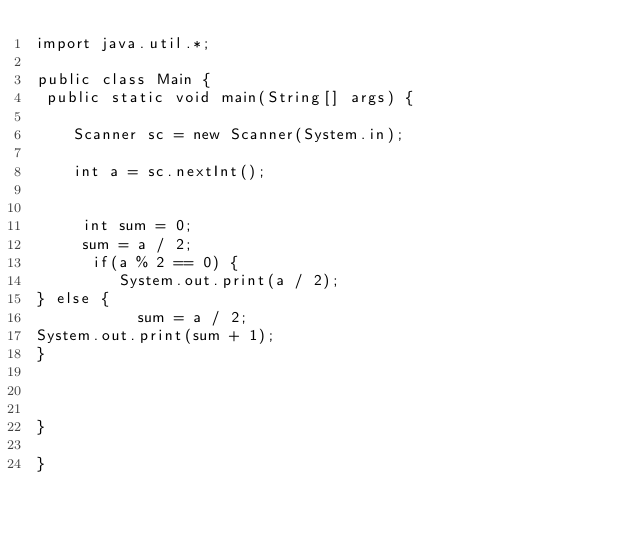Convert code to text. <code><loc_0><loc_0><loc_500><loc_500><_Java_>import java.util.*;

public class Main {
 public static void main(String[] args) {
  
    Scanner sc = new Scanner(System.in);
     
    int a = sc.nextInt();
    

     int sum = 0;
     sum = a / 2;
      if(a % 2 == 0) {
         System.out.print(a / 2); 
} else {
           sum = a / 2;
System.out.print(sum + 1); 
}

      

}

}</code> 